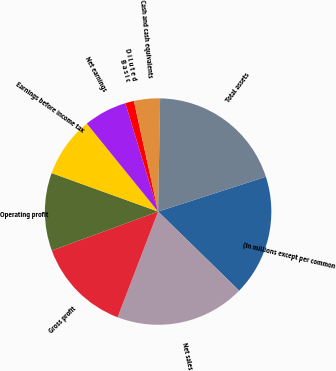<chart> <loc_0><loc_0><loc_500><loc_500><pie_chart><fcel>(In millions except per common<fcel>Net sales<fcel>Gross profit<fcel>Operating profit<fcel>Earnings before income tax<fcel>Net earnings<fcel>B a s i c<fcel>D i l u t e d<fcel>Cash and cash equivalents<fcel>Total assets<nl><fcel>17.28%<fcel>18.52%<fcel>13.58%<fcel>11.11%<fcel>8.64%<fcel>6.17%<fcel>1.24%<fcel>0.0%<fcel>3.71%<fcel>19.75%<nl></chart> 